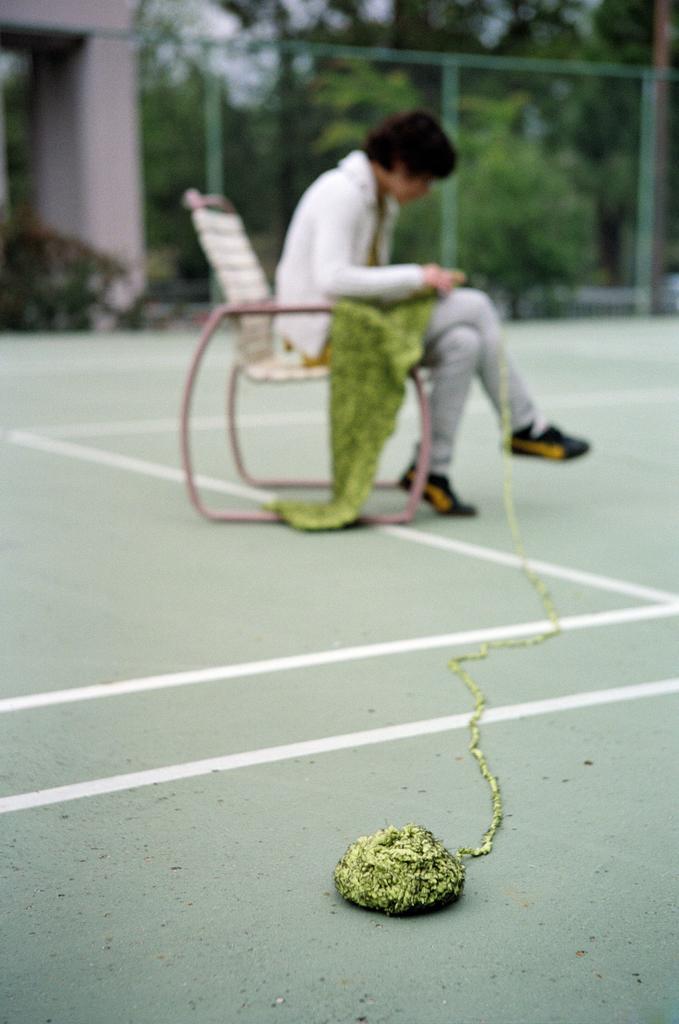Please provide a concise description of this image. There is a woolen bundle at the bottom side of the image, there is a lady sitting on a chair, it seems like weaving and there are trees, net fencing, a pillar and sky in the background area. 